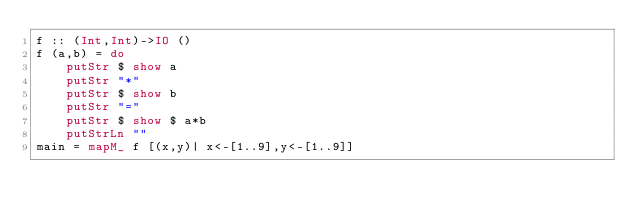Convert code to text. <code><loc_0><loc_0><loc_500><loc_500><_Haskell_>f :: (Int,Int)->IO ()
f (a,b) = do
    putStr $ show a
    putStr "*"
    putStr $ show b
    putStr "="
    putStr $ show $ a*b
    putStrLn ""
main = mapM_ f [(x,y)| x<-[1..9],y<-[1..9]]</code> 